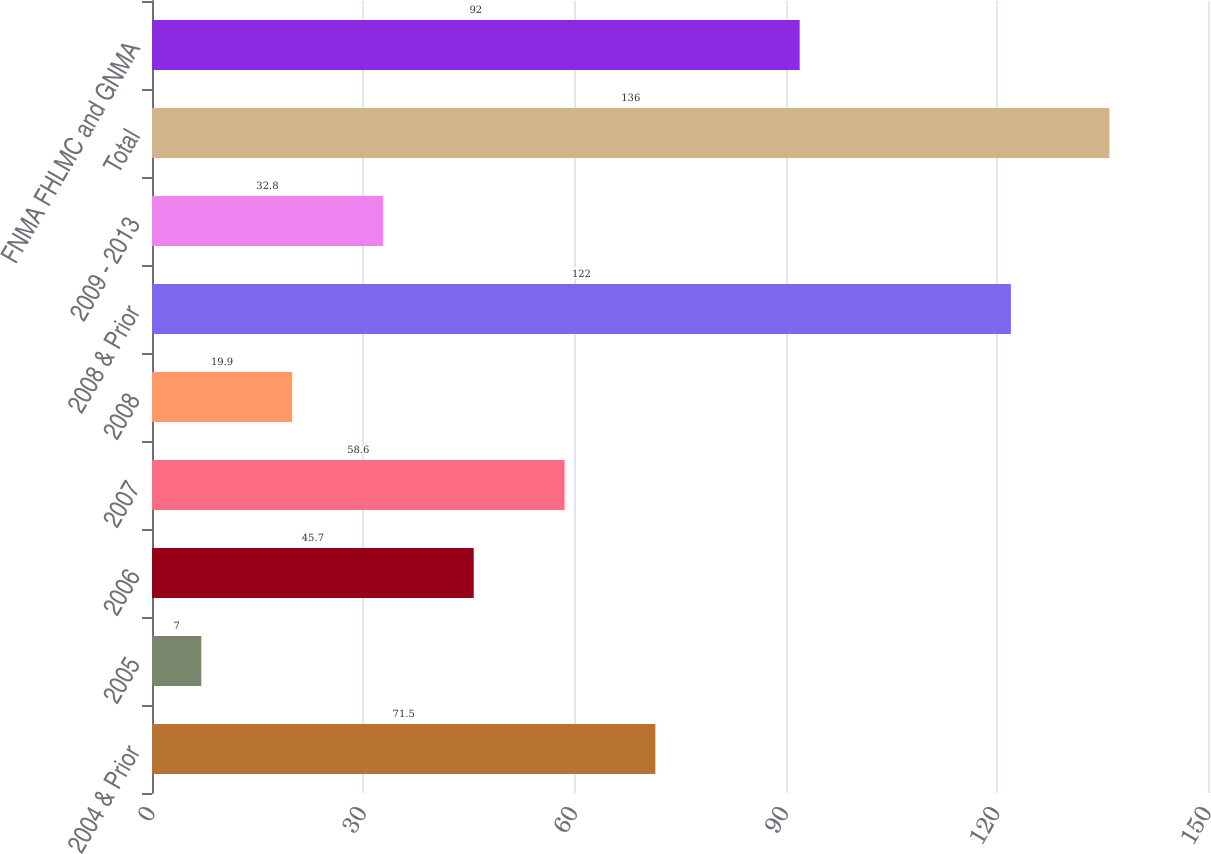Convert chart to OTSL. <chart><loc_0><loc_0><loc_500><loc_500><bar_chart><fcel>2004 & Prior<fcel>2005<fcel>2006<fcel>2007<fcel>2008<fcel>2008 & Prior<fcel>2009 - 2013<fcel>Total<fcel>FNMA FHLMC and GNMA<nl><fcel>71.5<fcel>7<fcel>45.7<fcel>58.6<fcel>19.9<fcel>122<fcel>32.8<fcel>136<fcel>92<nl></chart> 